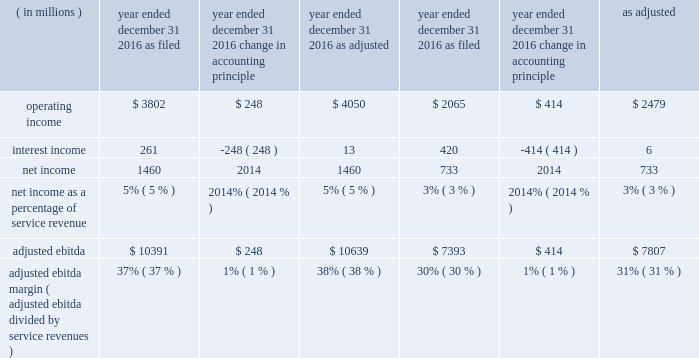Adjusted ebitda increased $ 574 million , or 5% ( 5 % ) , in 2017 primarily from : 2022 an increase in branded postpaid and prepaid service revenues primarily due to strong customer response to our un- carrier initiatives , the ongoing success of our promotional activities , and the continued strength of our metropcs brand ; 2022 higher wholesale revenues ; and 2022 higher other revenues ; partially offset by 2022 higher selling , general and administrative expenses ; 2022 lower gains on disposal of spectrum licenses of $ 600 million ; gains on disposal were $ 235 million for the year ended december 31 , 2017 , compared to $ 835 million in the same period in 2016 ; 2022 higher cost of services expense ; 2022 higher net losses on equipment ; and 2022 the negative impact from hurricanes of approximately $ 201 million , net of insurance recoveries .
Adjusted ebitda increased $ 2.8 billion , or 36% ( 36 % ) , in 2016 primarily from : 2022 increased branded postpaid and prepaid service revenues primarily due to strong customer response to our un-carrier initiatives and the ongoing success of our promotional activities ; 2022 higher gains on disposal of spectrum licenses of $ 672 million ; gains on disposal were $ 835 million in 2016 compared to $ 163 million in 2015 ; 2022 lower losses on equipment ; and 2022 focused cost control and synergies realized from the metropcs business combination , primarily in cost of services ; partially offset by 2022 higher selling , general and administrative .
Effective january 1 , 2017 , the imputed discount on eip receivables , which was previously recognized within interest income in our consolidated statements of comprehensive income , is recognized within other revenues in our consolidated statements of comprehensive income .
Due to this presentation , the imputed discount on eip receivables is included in adjusted ebitda .
See note 1 - summary of significant accounting policies of notes to the consolidated financial statements included in part ii , item 8 of this form 10-k for further information .
We have applied this change retrospectively and presented the effect on the years ended december 31 , 2016 and 2015 , in the table below. .
Adjusted ebitda margin ( adjusted ebitda divided by service revenues ) 37% ( 37 % ) 1% ( 1 % ) 38% ( 38 % ) 30% ( 30 % ) 1% ( 1 % ) 31% ( 31 % ) liquidity and capital resources our principal sources of liquidity are our cash and cash equivalents and cash generated from operations , proceeds from issuance of long-term debt and common stock , capital leases , the sale of certain receivables , financing arrangements of vendor payables which effectively extend payment terms and secured and unsecured revolving credit facilities with dt. .
What was the service revenue as of december 312016 in millions as filed? 
Rationale: the service revenue was derived based on the net income and net income as a percent of service revenue provided
Computations: (1460 / 5%)
Answer: 29200.0. Adjusted ebitda increased $ 574 million , or 5% ( 5 % ) , in 2017 primarily from : 2022 an increase in branded postpaid and prepaid service revenues primarily due to strong customer response to our un- carrier initiatives , the ongoing success of our promotional activities , and the continued strength of our metropcs brand ; 2022 higher wholesale revenues ; and 2022 higher other revenues ; partially offset by 2022 higher selling , general and administrative expenses ; 2022 lower gains on disposal of spectrum licenses of $ 600 million ; gains on disposal were $ 235 million for the year ended december 31 , 2017 , compared to $ 835 million in the same period in 2016 ; 2022 higher cost of services expense ; 2022 higher net losses on equipment ; and 2022 the negative impact from hurricanes of approximately $ 201 million , net of insurance recoveries .
Adjusted ebitda increased $ 2.8 billion , or 36% ( 36 % ) , in 2016 primarily from : 2022 increased branded postpaid and prepaid service revenues primarily due to strong customer response to our un-carrier initiatives and the ongoing success of our promotional activities ; 2022 higher gains on disposal of spectrum licenses of $ 672 million ; gains on disposal were $ 835 million in 2016 compared to $ 163 million in 2015 ; 2022 lower losses on equipment ; and 2022 focused cost control and synergies realized from the metropcs business combination , primarily in cost of services ; partially offset by 2022 higher selling , general and administrative .
Effective january 1 , 2017 , the imputed discount on eip receivables , which was previously recognized within interest income in our consolidated statements of comprehensive income , is recognized within other revenues in our consolidated statements of comprehensive income .
Due to this presentation , the imputed discount on eip receivables is included in adjusted ebitda .
See note 1 - summary of significant accounting policies of notes to the consolidated financial statements included in part ii , item 8 of this form 10-k for further information .
We have applied this change retrospectively and presented the effect on the years ended december 31 , 2016 and 2015 , in the table below. .
Adjusted ebitda margin ( adjusted ebitda divided by service revenues ) 37% ( 37 % ) 1% ( 1 % ) 38% ( 38 % ) 30% ( 30 % ) 1% ( 1 % ) 31% ( 31 % ) liquidity and capital resources our principal sources of liquidity are our cash and cash equivalents and cash generated from operations , proceeds from issuance of long-term debt and common stock , capital leases , the sale of certain receivables , financing arrangements of vendor payables which effectively extend payment terms and secured and unsecured revolving credit facilities with dt. .
What was the percent of the change in the disposal costs from 2016 to 2017? 
Rationale: in 2107 the was a 600 million reduction in disposal costs equal 71.9 % of the amount in 2016
Computations: (235 - 835)
Answer: -600.0. 